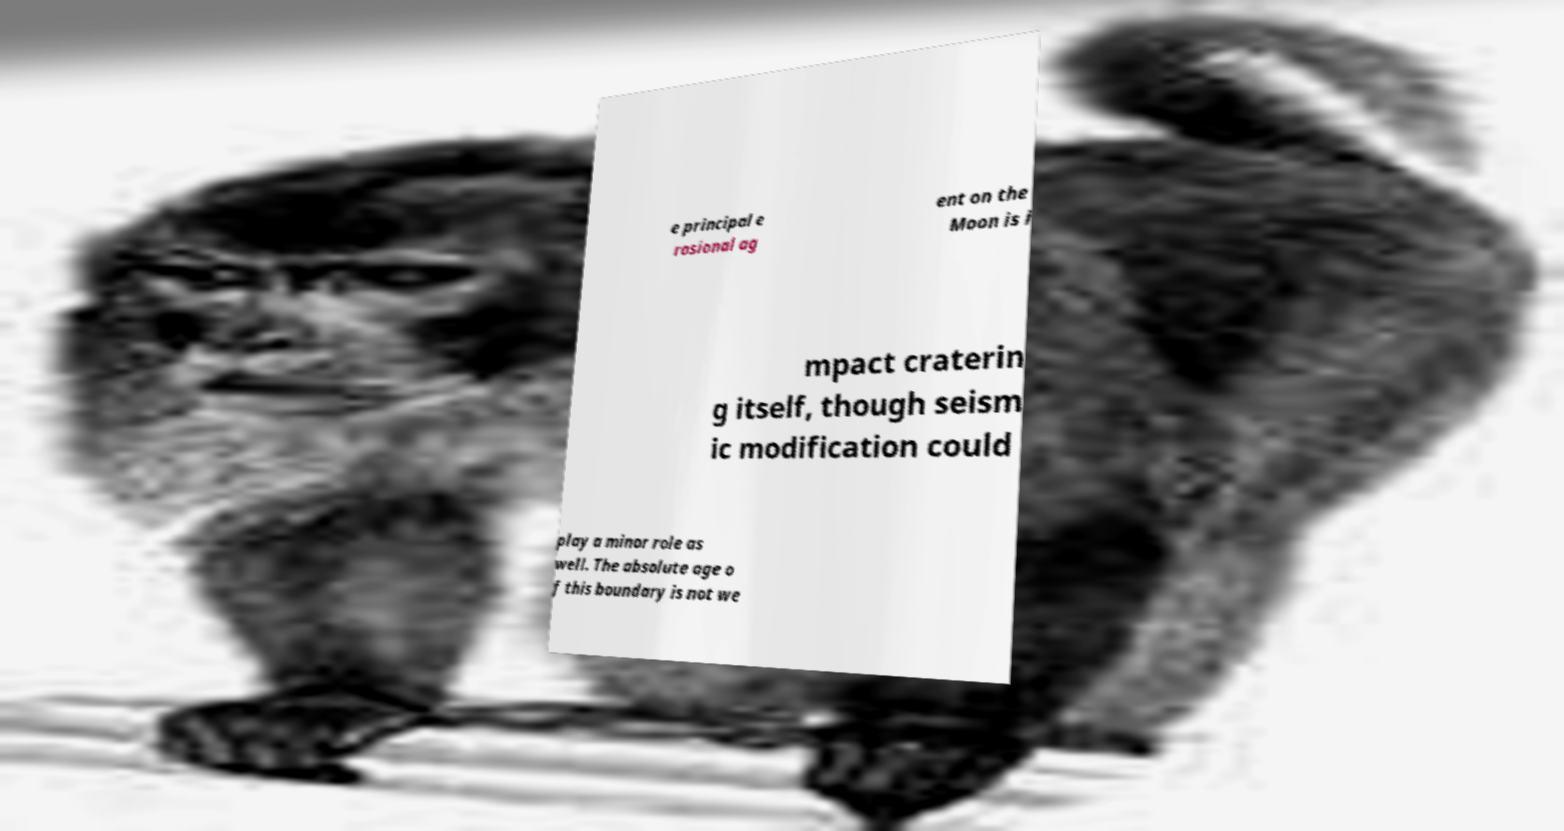Please identify and transcribe the text found in this image. e principal e rosional ag ent on the Moon is i mpact craterin g itself, though seism ic modification could play a minor role as well. The absolute age o f this boundary is not we 